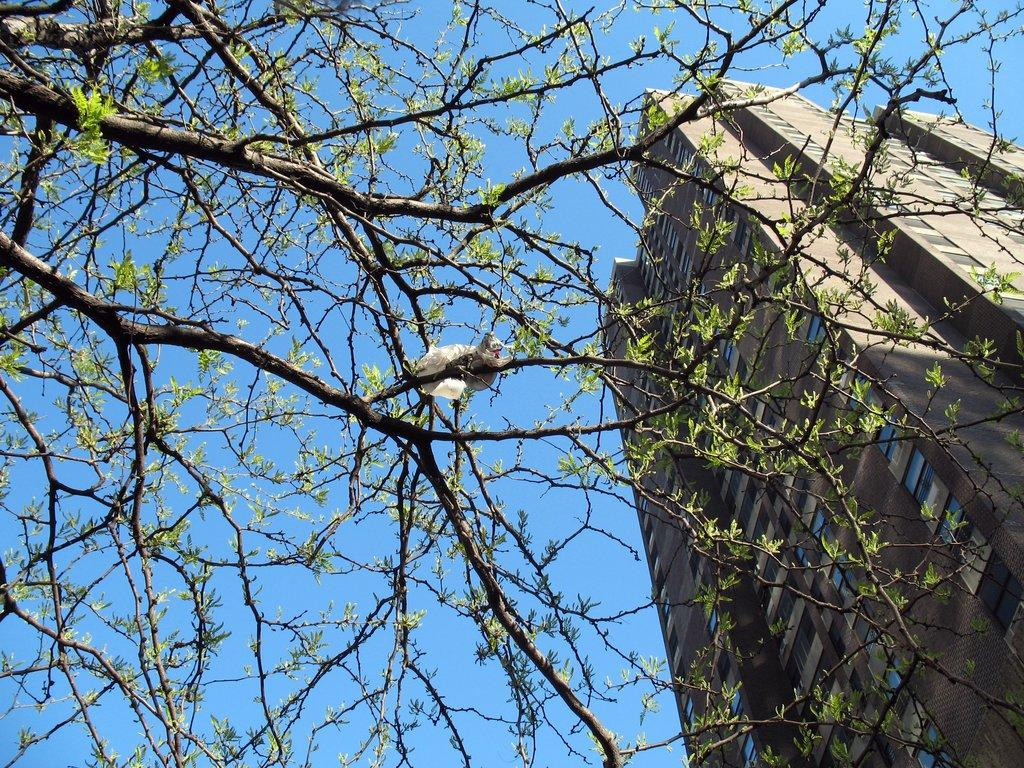What type of animal can be seen in the image? There is a bird in the image. Where is the bird located? The bird is sitting on a tree. What can be found on the tree besides the bird? There are leaves on the tree. What is visible on the right side of the image? There is a building on the right side of the image. What is the color of the sky in the image? The sky is blue in color. What type of trail does the bird leave behind as it flies in the image? There is no indication that the bird is flying in the image, and therefore no trail can be observed. 